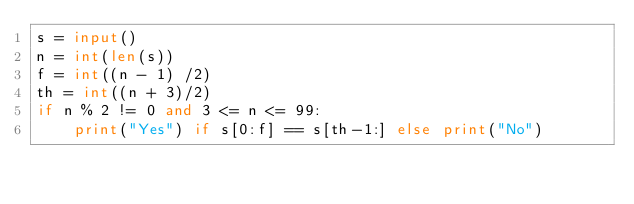Convert code to text. <code><loc_0><loc_0><loc_500><loc_500><_Python_>s = input()
n = int(len(s))
f = int((n - 1) /2)
th = int((n + 3)/2)
if n % 2 != 0 and 3 <= n <= 99:
    print("Yes") if s[0:f] == s[th-1:] else print("No")</code> 